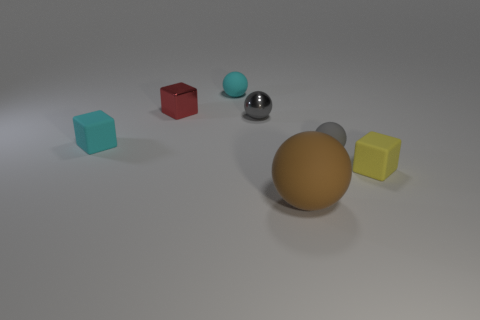Are there any other things that are the same size as the brown sphere?
Offer a very short reply. No. How many other things are there of the same shape as the large object?
Give a very brief answer. 3. There is a object behind the tiny red metal object; is its color the same as the tiny ball that is on the right side of the large brown thing?
Give a very brief answer. No. There is a gray object that is in front of the small rubber thing that is to the left of the red block on the left side of the gray matte thing; what size is it?
Give a very brief answer. Small. The tiny matte thing that is both to the left of the large rubber thing and on the right side of the red thing has what shape?
Give a very brief answer. Sphere. Are there an equal number of gray things in front of the gray shiny object and small rubber things that are on the right side of the large brown matte object?
Provide a short and direct response. No. Are there any small cyan spheres made of the same material as the red thing?
Your answer should be very brief. No. Does the small gray sphere that is on the right side of the large brown matte ball have the same material as the red cube?
Offer a terse response. No. What is the size of the block that is both to the right of the small cyan block and to the left of the brown object?
Your response must be concise. Small. What is the color of the small metallic sphere?
Ensure brevity in your answer.  Gray. 